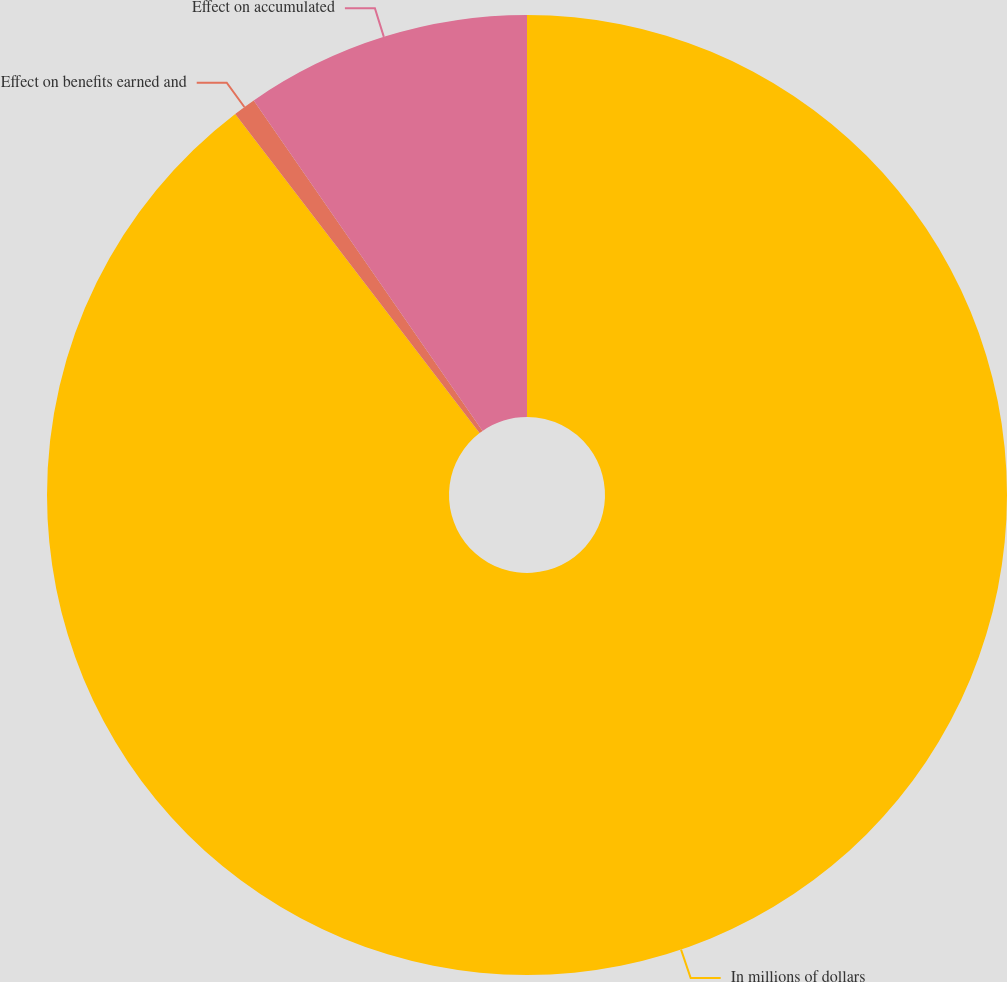Convert chart. <chart><loc_0><loc_0><loc_500><loc_500><pie_chart><fcel>In millions of dollars<fcel>Effect on benefits earned and<fcel>Effect on accumulated<nl><fcel>89.6%<fcel>0.76%<fcel>9.64%<nl></chart> 